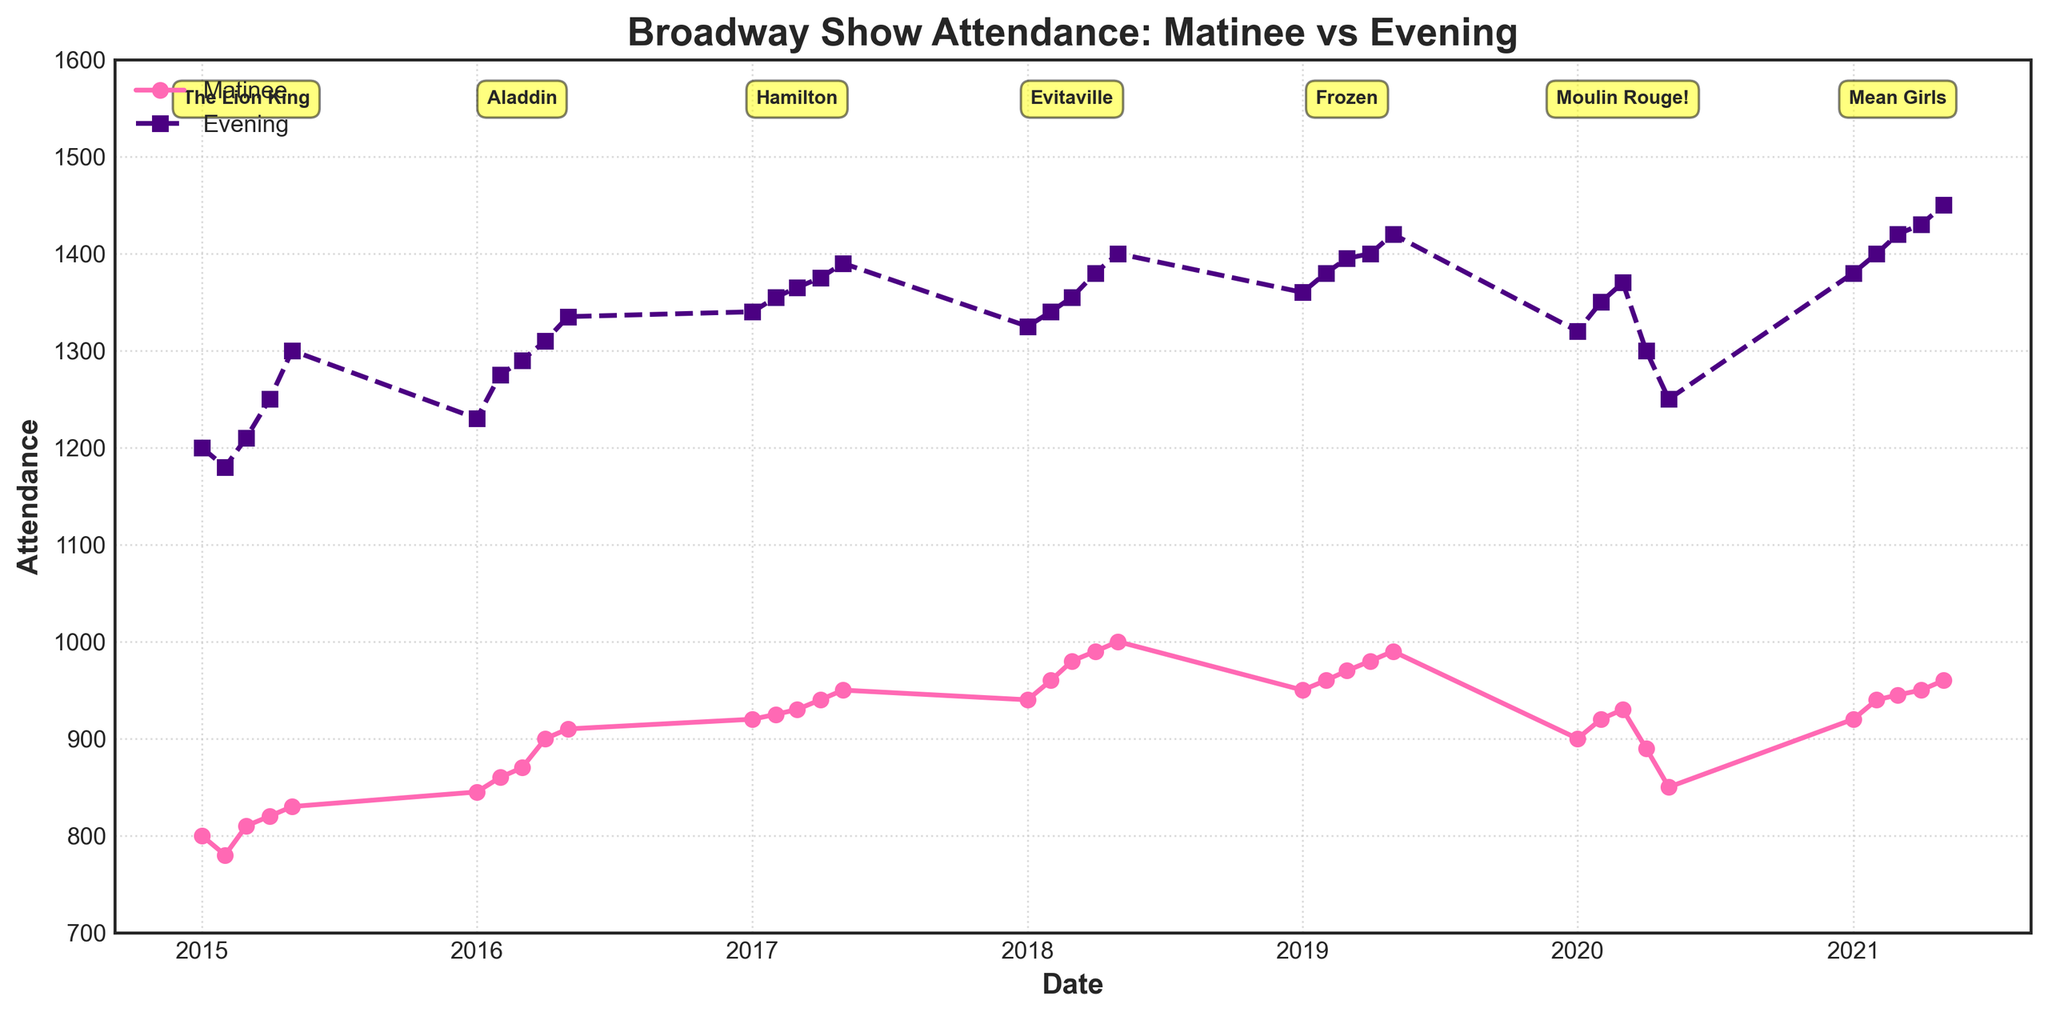What is the title of the figure? The title can be found at the top of the figure, typically centered and in bold font.
Answer: Broadway Show Attendance: Matinee vs Evening Which color represents the Matinee attendance, and which represents the Evening attendance? By observing the lines and their corresponding labels in the legend, we can determine that the Matinee attendance is represented in pink and the Evening attendance in dark purple.
Answer: Matinee - pink, Evening - dark purple How does the attendance generally trend over time for Matinee performances from 2015 to 2021? The Matinee attendance starts at around 800 in 2015 and shows a general upward trend, peaking at 960 in 2021, with some fluctuations.
Answer: Upward trend What is the approximate difference between Matinee and Evening attendance in May 2015? By looking at the plot around May 2015, we see Matinee attendance is around 830 and Evening attendance is around 1300. The difference is 1300 - 830.
Answer: 470 Which show had the highest attendance figures for Matinee performances, and in what year? By comparing the highest points of the pink line and noting the annotations for each show, we identify the highest Matinee attendance at 1000 in May 2018 for the show Evitaville.
Answer: Evitaville, 2018 What are the two shows with the closest Matinee and Evening attendance figures? We need to observe the points where the pink and dark purple lines are closest to each other across the timeline. They appear closest for the show Mean Girls in 2021, where Matinee is 960 and Evening is 1450, and for Moulin Rouge! in 2020, where the lines also get close.
Answer: Mean Girls, Moulin Rouge! Did the Evening attendance ever drop below 1200 during the time period? By observing the lowest points of the dark purple line, we see that the Evening attendance never drops below 1200; all values stay above this figure.
Answer: No How did the attendance figures for Hamilton compare to the previous show? The previous show before Hamilton was Aladdin. By comparing the points in 2017 to those in 2016, we see Hamilton's attendance was slightly higher than Aladdin's for both Matinee and Evening performances.
Answer: Higher Identify the year when there was a notable dip in attendance for both Matinee and Evening shows. By looking at dips in the plots, 2020 stands out with a visible decline in both Matinee and Evening attendance figures, especially in April and May.
Answer: 2020 Which year shows the greatest variation in Matinee attendance within the year itself? We need to observe the fluctuation of pink data points within each year, noticing that 2020 shows significant variation with attendance swinging from 920 to 850.
Answer: 2020 